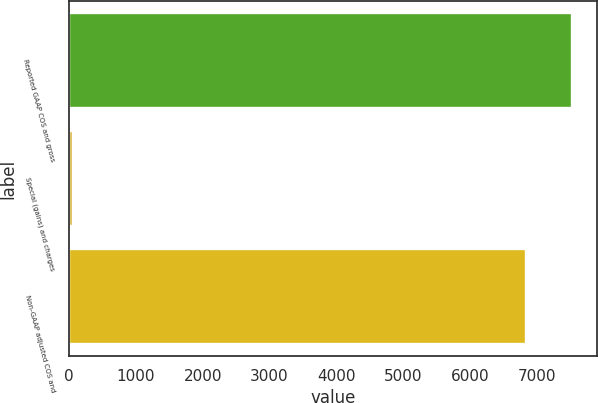Convert chart to OTSL. <chart><loc_0><loc_0><loc_500><loc_500><bar_chart><fcel>Reported GAAP COS and gross<fcel>Special (gains) and charges<fcel>Non-GAAP adjusted COS and<nl><fcel>7516.19<fcel>66<fcel>6832.9<nl></chart> 